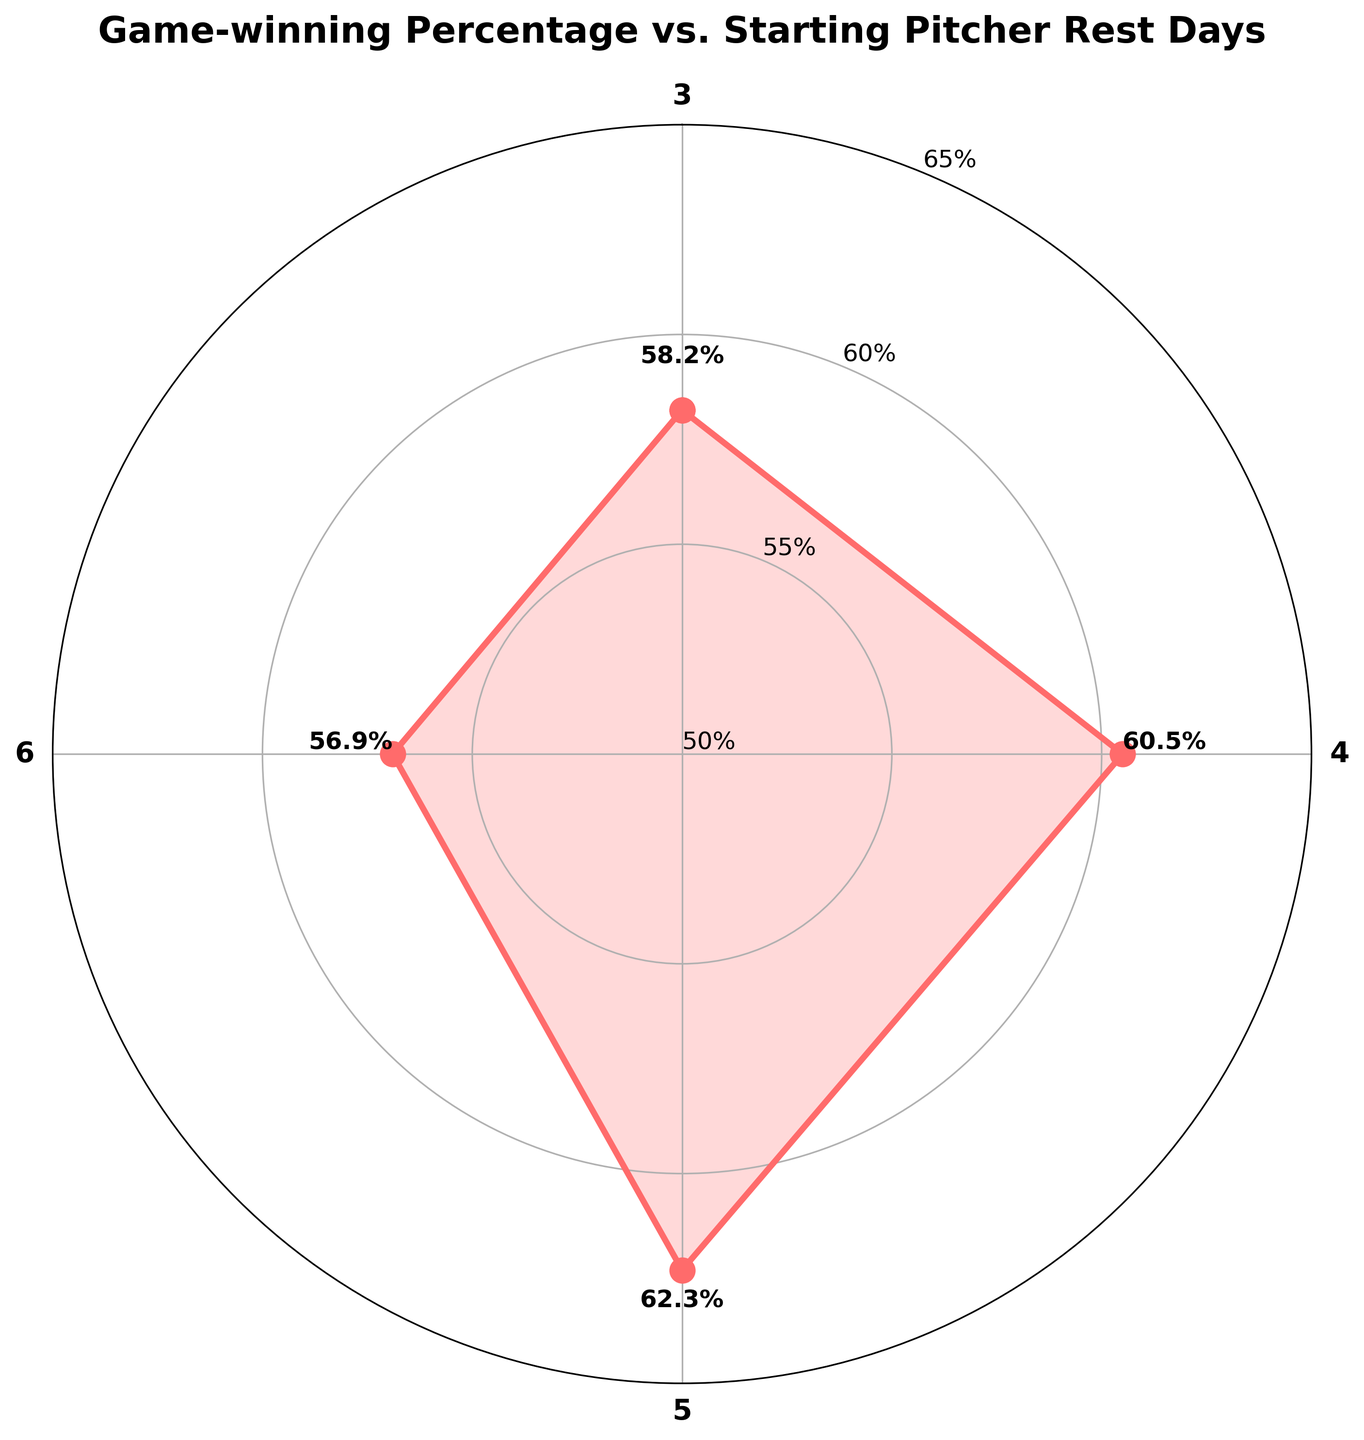What is the title of the figure? The title is located at the top of the figure, it reads "Game-winning Percentage vs. Starting Pitcher Rest Days".
Answer: Game-winning Percentage vs. Starting Pitcher Rest Days How many groups are shown in the figure? The figure contains data points for 3, 4, 5, and 6 rest days, so there are 4 groups shown.
Answer: 4 What is the winning percentage for pitchers with 5 rest days? Look at the label next to the data point corresponding to 5 rest days. It reads 62.3%.
Answer: 62.3% Which rest day has the highest game-winning percentage? Compare the winning percentages given for each rest day. The highest value is for 5 rest days with 62.3%.
Answer: 5 rest days Which rest day has the lowest game-winning percentage? Compare the winning percentages given for each rest day. The lowest value is for 6 rest days with 56.9%.
Answer: 6 rest days What is the difference in winning percentage between 3 rest days and 5 rest days? Subtract the winning percentage of 3 rest days from that of 5 rest days: 62.3% - 58.2% = 4.1%.
Answer: 4.1% How does the winning percentage change from 3 rest days to 4 rest days? Compare the winning percentages for 3 and 4 rest days. It increases from 58.2% to 60.5%, thus an increase of 2.3%.
Answer: Increases by 2.3% What is the average winning percentage across all rest days? Sum all the winning percentages (58.2 + 60.5 + 62.3 + 56.9) and divide by the number of rest days (4). The average is (238.0) / 4 = 59.5%.
Answer: 59.5% 